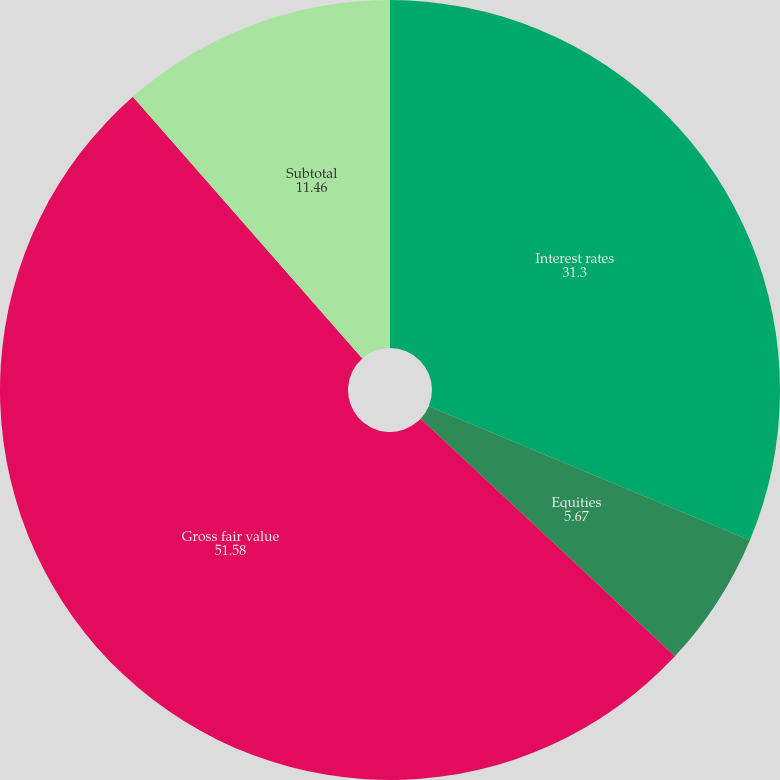Convert chart to OTSL. <chart><loc_0><loc_0><loc_500><loc_500><pie_chart><fcel>Interest rates<fcel>Equities<fcel>Gross fair value<fcel>Subtotal<nl><fcel>31.3%<fcel>5.67%<fcel>51.58%<fcel>11.46%<nl></chart> 